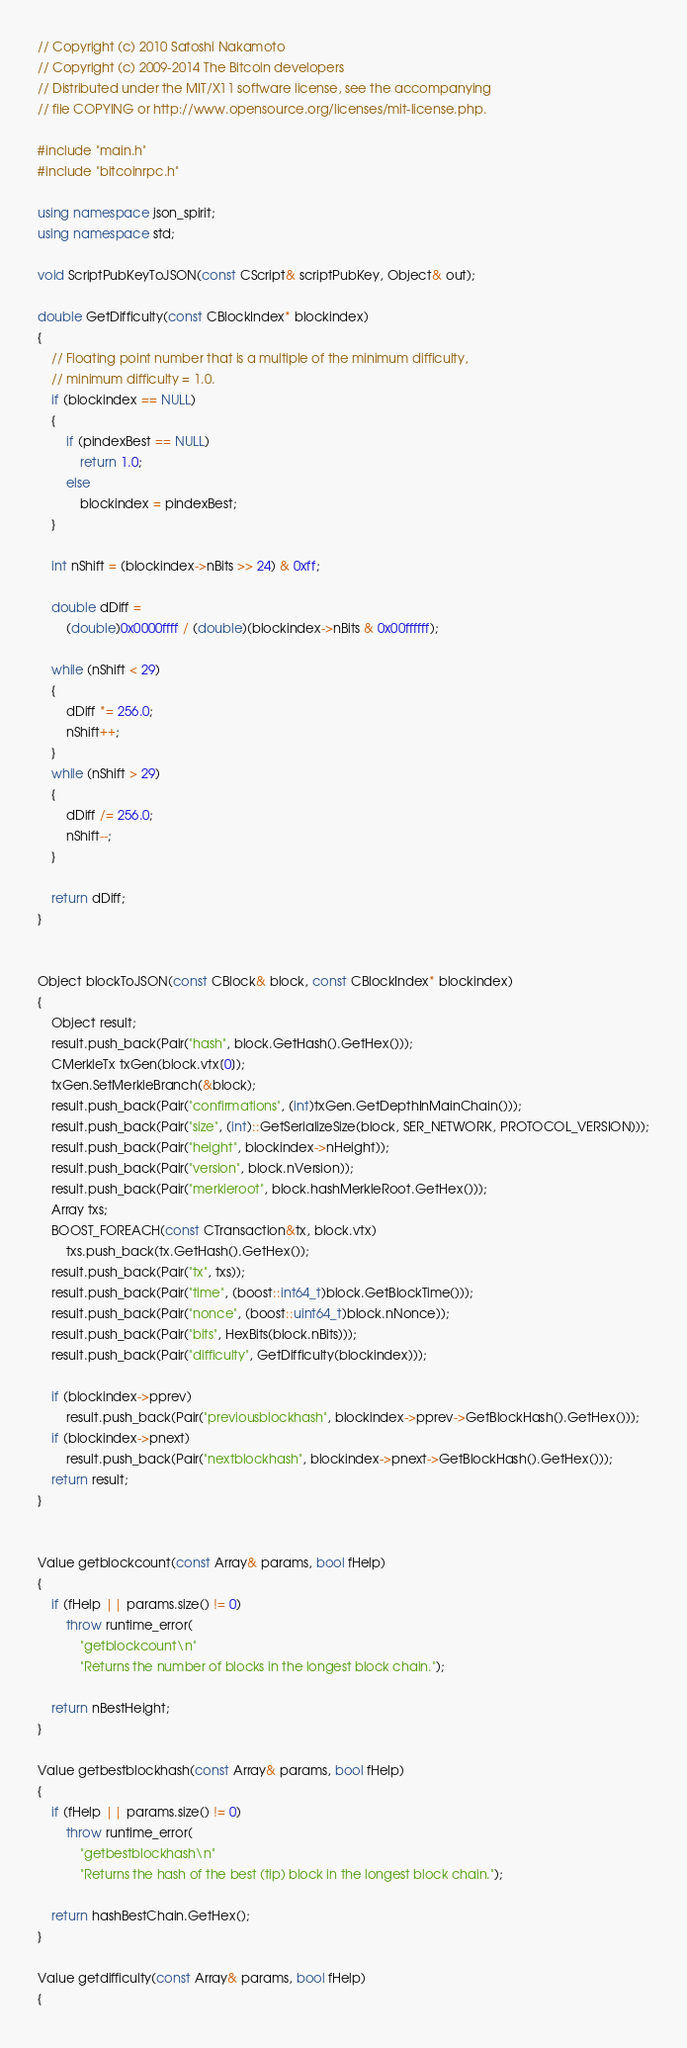<code> <loc_0><loc_0><loc_500><loc_500><_C++_>// Copyright (c) 2010 Satoshi Nakamoto
// Copyright (c) 2009-2014 The Bitcoin developers
// Distributed under the MIT/X11 software license, see the accompanying
// file COPYING or http://www.opensource.org/licenses/mit-license.php.

#include "main.h"
#include "bitcoinrpc.h"

using namespace json_spirit;
using namespace std;

void ScriptPubKeyToJSON(const CScript& scriptPubKey, Object& out);

double GetDifficulty(const CBlockIndex* blockindex)
{
    // Floating point number that is a multiple of the minimum difficulty,
    // minimum difficulty = 1.0.
    if (blockindex == NULL)
    {
        if (pindexBest == NULL)
            return 1.0;
        else
            blockindex = pindexBest;
    }

    int nShift = (blockindex->nBits >> 24) & 0xff;

    double dDiff =
        (double)0x0000ffff / (double)(blockindex->nBits & 0x00ffffff);

    while (nShift < 29)
    {
        dDiff *= 256.0;
        nShift++;
    }
    while (nShift > 29)
    {
        dDiff /= 256.0;
        nShift--;
    }

    return dDiff;
}


Object blockToJSON(const CBlock& block, const CBlockIndex* blockindex)
{
    Object result;
    result.push_back(Pair("hash", block.GetHash().GetHex()));
    CMerkleTx txGen(block.vtx[0]);
    txGen.SetMerkleBranch(&block);
    result.push_back(Pair("confirmations", (int)txGen.GetDepthInMainChain()));
    result.push_back(Pair("size", (int)::GetSerializeSize(block, SER_NETWORK, PROTOCOL_VERSION)));
    result.push_back(Pair("height", blockindex->nHeight));
    result.push_back(Pair("version", block.nVersion));
    result.push_back(Pair("merkleroot", block.hashMerkleRoot.GetHex()));
    Array txs;
    BOOST_FOREACH(const CTransaction&tx, block.vtx)
        txs.push_back(tx.GetHash().GetHex());
    result.push_back(Pair("tx", txs));
    result.push_back(Pair("time", (boost::int64_t)block.GetBlockTime()));
    result.push_back(Pair("nonce", (boost::uint64_t)block.nNonce));
    result.push_back(Pair("bits", HexBits(block.nBits)));
    result.push_back(Pair("difficulty", GetDifficulty(blockindex)));

    if (blockindex->pprev)
        result.push_back(Pair("previousblockhash", blockindex->pprev->GetBlockHash().GetHex()));
    if (blockindex->pnext)
        result.push_back(Pair("nextblockhash", blockindex->pnext->GetBlockHash().GetHex()));
    return result;
}


Value getblockcount(const Array& params, bool fHelp)
{
    if (fHelp || params.size() != 0)
        throw runtime_error(
            "getblockcount\n"
            "Returns the number of blocks in the longest block chain.");

    return nBestHeight;
}

Value getbestblockhash(const Array& params, bool fHelp)
{
    if (fHelp || params.size() != 0)
        throw runtime_error(
            "getbestblockhash\n"
            "Returns the hash of the best (tip) block in the longest block chain.");

    return hashBestChain.GetHex();
}

Value getdifficulty(const Array& params, bool fHelp)
{</code> 